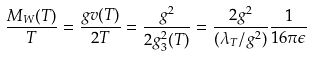Convert formula to latex. <formula><loc_0><loc_0><loc_500><loc_500>\frac { M _ { W } ( T ) } { T } = \frac { g v ( T ) } { 2 T } = \frac { g ^ { 2 } } { 2 g ^ { 2 } _ { 3 } ( T ) } = \frac { 2 g ^ { 2 } } { ( \lambda _ { T } / g ^ { 2 } ) } \frac { 1 } { 1 6 \pi \epsilon }</formula> 